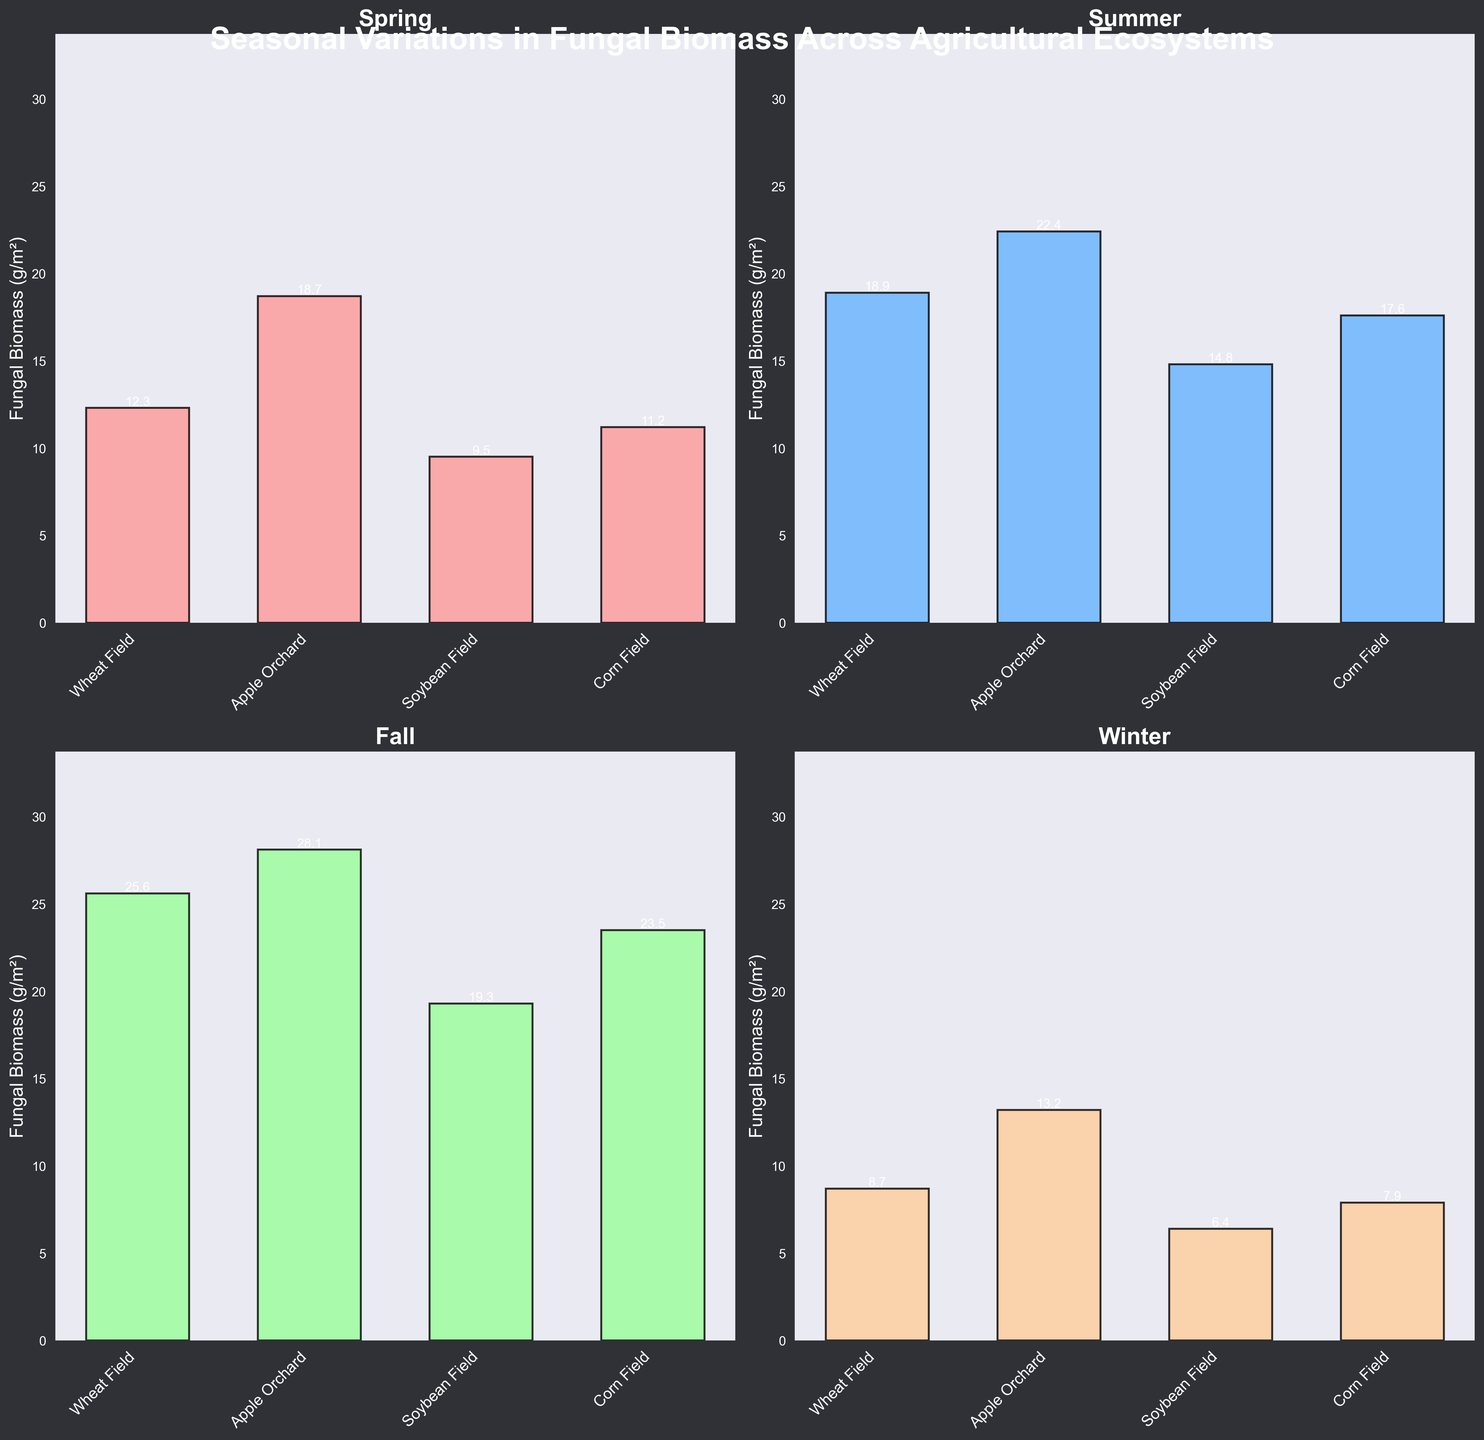what is the title of the chart? The title of the chart is displayed at the top of the figure in bold and large font.
Answer: Seasonal Variations in Fungal Biomass Across Agricultural Ecosystems which season has the highest fungal biomass in apple orchards? By visually inspecting the bar heights in the subplot for all seasons, the Summer season shows the highest bar for Apple Orchards.
Answer: Fall what is the fungal biomass value in soybean fields during winter? Look at the Winter subplot and find the bar corresponding to Soybean Field. The height value labeled is noted.
Answer: 6.4 g/m² how much more fungal biomass is found in corn fields during fall compared to spring? Find the bars for Fall and Spring in the Corn Field subplots. The values are 23.5 g/m² for Fall and 11.2 g/m² for Spring. Subtract these to find the difference.
Answer: 12.3 g/m² which seasonal subplot has the smallest range of fungal biomass values across all ecosystems? Compare the difference between the highest and lowest bar within each subplot. The Winter subplot has the smallest range (13.2 - 6.4 = 6.8).
Answer: Winter what is the total fungal biomass in wheat fields over all seasons? Sum the bar heights of Wheat Field in all subplots (Spring: 12.3, Summer: 18.9, Fall: 25.6, Winter: 8.7). The total is 65.5 g/m²
Answer: 65.5 g/m² in which season does soybean field have the second lowest fungal biomass? For each seasonal subplot, identify the bar height for Soybean Fields, then rank them. Spring has the second lowest value for Soybean Fields.
Answer: Spring which ecosystem shows consistent increase in fungal biomass from spring to fall? Compare bar heights for each ecosystem across Spring, Summer, and Fall subplots. Apple Orchard's bar heights show a consistent increase.
Answer: Apple Orchard how does the fungal biomass in corn fields during summer compare to spring? Check the bar heights for Corn Field in Spring and Summer subplots. Summer (17.6 g/m²) is higher than Spring (11.2 g/m²).
Answer: It is higher 